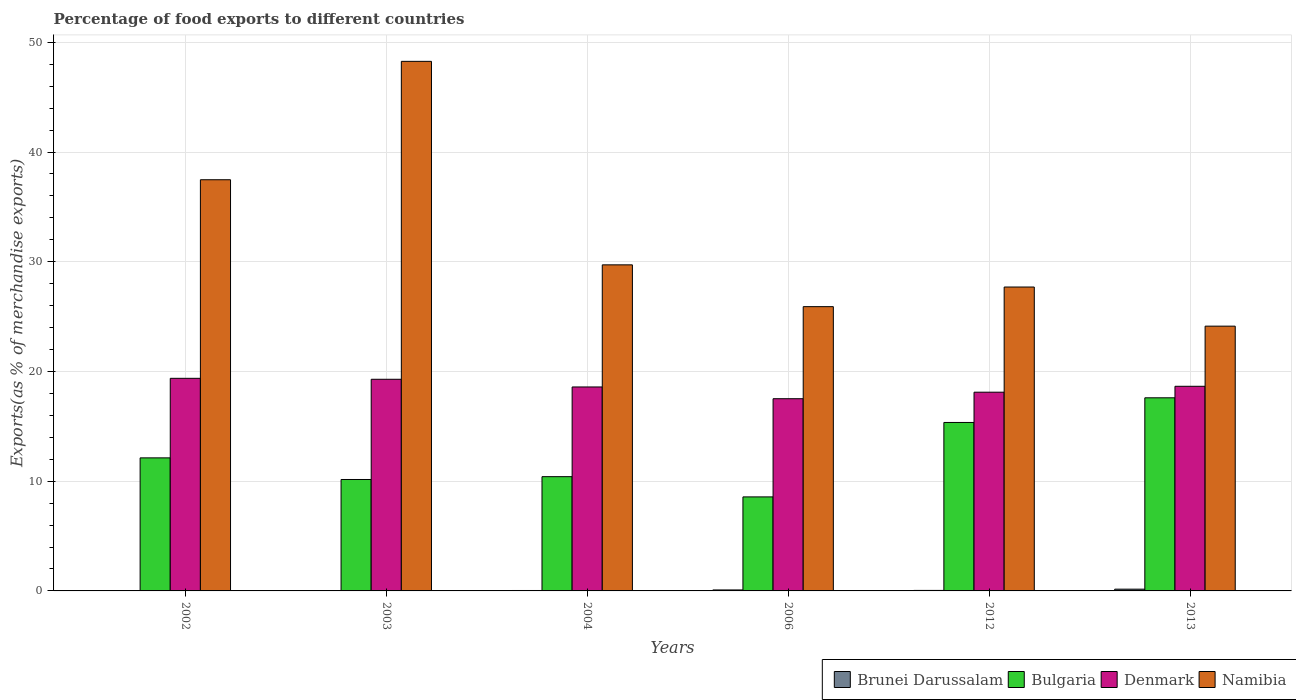How many different coloured bars are there?
Your answer should be compact. 4. Are the number of bars per tick equal to the number of legend labels?
Offer a very short reply. Yes. How many bars are there on the 6th tick from the left?
Ensure brevity in your answer.  4. What is the label of the 6th group of bars from the left?
Offer a very short reply. 2013. In how many cases, is the number of bars for a given year not equal to the number of legend labels?
Provide a succinct answer. 0. What is the percentage of exports to different countries in Denmark in 2002?
Your response must be concise. 19.38. Across all years, what is the maximum percentage of exports to different countries in Namibia?
Give a very brief answer. 48.27. Across all years, what is the minimum percentage of exports to different countries in Brunei Darussalam?
Offer a very short reply. 0.02. What is the total percentage of exports to different countries in Brunei Darussalam in the graph?
Offer a terse response. 0.37. What is the difference between the percentage of exports to different countries in Bulgaria in 2003 and that in 2006?
Provide a succinct answer. 1.59. What is the difference between the percentage of exports to different countries in Namibia in 2006 and the percentage of exports to different countries in Denmark in 2004?
Give a very brief answer. 7.32. What is the average percentage of exports to different countries in Brunei Darussalam per year?
Make the answer very short. 0.06. In the year 2006, what is the difference between the percentage of exports to different countries in Brunei Darussalam and percentage of exports to different countries in Bulgaria?
Provide a succinct answer. -8.48. What is the ratio of the percentage of exports to different countries in Denmark in 2002 to that in 2013?
Give a very brief answer. 1.04. Is the percentage of exports to different countries in Namibia in 2004 less than that in 2006?
Offer a very short reply. No. What is the difference between the highest and the second highest percentage of exports to different countries in Denmark?
Provide a short and direct response. 0.09. What is the difference between the highest and the lowest percentage of exports to different countries in Denmark?
Ensure brevity in your answer.  1.86. In how many years, is the percentage of exports to different countries in Bulgaria greater than the average percentage of exports to different countries in Bulgaria taken over all years?
Give a very brief answer. 2. Is the sum of the percentage of exports to different countries in Denmark in 2004 and 2013 greater than the maximum percentage of exports to different countries in Brunei Darussalam across all years?
Your answer should be compact. Yes. What does the 2nd bar from the left in 2006 represents?
Ensure brevity in your answer.  Bulgaria. What does the 3rd bar from the right in 2013 represents?
Keep it short and to the point. Bulgaria. How many years are there in the graph?
Provide a short and direct response. 6. What is the difference between two consecutive major ticks on the Y-axis?
Offer a terse response. 10. Does the graph contain grids?
Keep it short and to the point. Yes. How many legend labels are there?
Keep it short and to the point. 4. What is the title of the graph?
Offer a terse response. Percentage of food exports to different countries. Does "Uganda" appear as one of the legend labels in the graph?
Your answer should be very brief. No. What is the label or title of the Y-axis?
Your response must be concise. Exports(as % of merchandise exports). What is the Exports(as % of merchandise exports) of Brunei Darussalam in 2002?
Your answer should be compact. 0.02. What is the Exports(as % of merchandise exports) in Bulgaria in 2002?
Your answer should be very brief. 12.13. What is the Exports(as % of merchandise exports) of Denmark in 2002?
Provide a succinct answer. 19.38. What is the Exports(as % of merchandise exports) in Namibia in 2002?
Offer a very short reply. 37.48. What is the Exports(as % of merchandise exports) in Brunei Darussalam in 2003?
Offer a very short reply. 0.02. What is the Exports(as % of merchandise exports) in Bulgaria in 2003?
Offer a terse response. 10.16. What is the Exports(as % of merchandise exports) in Denmark in 2003?
Make the answer very short. 19.29. What is the Exports(as % of merchandise exports) of Namibia in 2003?
Your response must be concise. 48.27. What is the Exports(as % of merchandise exports) in Brunei Darussalam in 2004?
Your response must be concise. 0.04. What is the Exports(as % of merchandise exports) of Bulgaria in 2004?
Provide a succinct answer. 10.41. What is the Exports(as % of merchandise exports) in Denmark in 2004?
Provide a short and direct response. 18.59. What is the Exports(as % of merchandise exports) in Namibia in 2004?
Provide a succinct answer. 29.72. What is the Exports(as % of merchandise exports) in Brunei Darussalam in 2006?
Offer a terse response. 0.09. What is the Exports(as % of merchandise exports) in Bulgaria in 2006?
Offer a very short reply. 8.57. What is the Exports(as % of merchandise exports) of Denmark in 2006?
Your answer should be very brief. 17.52. What is the Exports(as % of merchandise exports) of Namibia in 2006?
Your answer should be very brief. 25.91. What is the Exports(as % of merchandise exports) of Brunei Darussalam in 2012?
Ensure brevity in your answer.  0.05. What is the Exports(as % of merchandise exports) in Bulgaria in 2012?
Ensure brevity in your answer.  15.35. What is the Exports(as % of merchandise exports) in Denmark in 2012?
Offer a terse response. 18.11. What is the Exports(as % of merchandise exports) of Namibia in 2012?
Keep it short and to the point. 27.7. What is the Exports(as % of merchandise exports) in Brunei Darussalam in 2013?
Your response must be concise. 0.16. What is the Exports(as % of merchandise exports) of Bulgaria in 2013?
Keep it short and to the point. 17.6. What is the Exports(as % of merchandise exports) in Denmark in 2013?
Make the answer very short. 18.65. What is the Exports(as % of merchandise exports) of Namibia in 2013?
Give a very brief answer. 24.13. Across all years, what is the maximum Exports(as % of merchandise exports) in Brunei Darussalam?
Offer a very short reply. 0.16. Across all years, what is the maximum Exports(as % of merchandise exports) of Bulgaria?
Ensure brevity in your answer.  17.6. Across all years, what is the maximum Exports(as % of merchandise exports) of Denmark?
Your response must be concise. 19.38. Across all years, what is the maximum Exports(as % of merchandise exports) of Namibia?
Make the answer very short. 48.27. Across all years, what is the minimum Exports(as % of merchandise exports) in Brunei Darussalam?
Provide a succinct answer. 0.02. Across all years, what is the minimum Exports(as % of merchandise exports) in Bulgaria?
Ensure brevity in your answer.  8.57. Across all years, what is the minimum Exports(as % of merchandise exports) in Denmark?
Give a very brief answer. 17.52. Across all years, what is the minimum Exports(as % of merchandise exports) in Namibia?
Offer a very short reply. 24.13. What is the total Exports(as % of merchandise exports) in Brunei Darussalam in the graph?
Keep it short and to the point. 0.37. What is the total Exports(as % of merchandise exports) in Bulgaria in the graph?
Give a very brief answer. 74.22. What is the total Exports(as % of merchandise exports) in Denmark in the graph?
Provide a succinct answer. 111.54. What is the total Exports(as % of merchandise exports) of Namibia in the graph?
Provide a short and direct response. 193.2. What is the difference between the Exports(as % of merchandise exports) of Bulgaria in 2002 and that in 2003?
Your answer should be compact. 1.97. What is the difference between the Exports(as % of merchandise exports) of Denmark in 2002 and that in 2003?
Your answer should be very brief. 0.09. What is the difference between the Exports(as % of merchandise exports) of Namibia in 2002 and that in 2003?
Your response must be concise. -10.79. What is the difference between the Exports(as % of merchandise exports) in Brunei Darussalam in 2002 and that in 2004?
Your answer should be very brief. -0.02. What is the difference between the Exports(as % of merchandise exports) of Bulgaria in 2002 and that in 2004?
Your answer should be very brief. 1.71. What is the difference between the Exports(as % of merchandise exports) in Denmark in 2002 and that in 2004?
Provide a succinct answer. 0.79. What is the difference between the Exports(as % of merchandise exports) in Namibia in 2002 and that in 2004?
Offer a terse response. 7.76. What is the difference between the Exports(as % of merchandise exports) of Brunei Darussalam in 2002 and that in 2006?
Provide a succinct answer. -0.07. What is the difference between the Exports(as % of merchandise exports) of Bulgaria in 2002 and that in 2006?
Offer a terse response. 3.56. What is the difference between the Exports(as % of merchandise exports) of Denmark in 2002 and that in 2006?
Ensure brevity in your answer.  1.86. What is the difference between the Exports(as % of merchandise exports) of Namibia in 2002 and that in 2006?
Ensure brevity in your answer.  11.57. What is the difference between the Exports(as % of merchandise exports) of Brunei Darussalam in 2002 and that in 2012?
Provide a succinct answer. -0.03. What is the difference between the Exports(as % of merchandise exports) of Bulgaria in 2002 and that in 2012?
Keep it short and to the point. -3.23. What is the difference between the Exports(as % of merchandise exports) in Denmark in 2002 and that in 2012?
Your response must be concise. 1.27. What is the difference between the Exports(as % of merchandise exports) in Namibia in 2002 and that in 2012?
Ensure brevity in your answer.  9.78. What is the difference between the Exports(as % of merchandise exports) of Brunei Darussalam in 2002 and that in 2013?
Offer a terse response. -0.14. What is the difference between the Exports(as % of merchandise exports) of Bulgaria in 2002 and that in 2013?
Offer a terse response. -5.47. What is the difference between the Exports(as % of merchandise exports) in Denmark in 2002 and that in 2013?
Your answer should be very brief. 0.73. What is the difference between the Exports(as % of merchandise exports) in Namibia in 2002 and that in 2013?
Your answer should be very brief. 13.35. What is the difference between the Exports(as % of merchandise exports) of Brunei Darussalam in 2003 and that in 2004?
Ensure brevity in your answer.  -0.02. What is the difference between the Exports(as % of merchandise exports) of Bulgaria in 2003 and that in 2004?
Provide a short and direct response. -0.26. What is the difference between the Exports(as % of merchandise exports) of Denmark in 2003 and that in 2004?
Give a very brief answer. 0.7. What is the difference between the Exports(as % of merchandise exports) in Namibia in 2003 and that in 2004?
Your answer should be compact. 18.55. What is the difference between the Exports(as % of merchandise exports) of Brunei Darussalam in 2003 and that in 2006?
Provide a succinct answer. -0.07. What is the difference between the Exports(as % of merchandise exports) in Bulgaria in 2003 and that in 2006?
Ensure brevity in your answer.  1.59. What is the difference between the Exports(as % of merchandise exports) in Denmark in 2003 and that in 2006?
Ensure brevity in your answer.  1.77. What is the difference between the Exports(as % of merchandise exports) in Namibia in 2003 and that in 2006?
Keep it short and to the point. 22.36. What is the difference between the Exports(as % of merchandise exports) of Brunei Darussalam in 2003 and that in 2012?
Provide a short and direct response. -0.03. What is the difference between the Exports(as % of merchandise exports) in Bulgaria in 2003 and that in 2012?
Your response must be concise. -5.2. What is the difference between the Exports(as % of merchandise exports) of Denmark in 2003 and that in 2012?
Your response must be concise. 1.18. What is the difference between the Exports(as % of merchandise exports) of Namibia in 2003 and that in 2012?
Your response must be concise. 20.57. What is the difference between the Exports(as % of merchandise exports) of Brunei Darussalam in 2003 and that in 2013?
Provide a succinct answer. -0.14. What is the difference between the Exports(as % of merchandise exports) in Bulgaria in 2003 and that in 2013?
Ensure brevity in your answer.  -7.44. What is the difference between the Exports(as % of merchandise exports) of Denmark in 2003 and that in 2013?
Give a very brief answer. 0.64. What is the difference between the Exports(as % of merchandise exports) in Namibia in 2003 and that in 2013?
Give a very brief answer. 24.14. What is the difference between the Exports(as % of merchandise exports) in Brunei Darussalam in 2004 and that in 2006?
Ensure brevity in your answer.  -0.05. What is the difference between the Exports(as % of merchandise exports) of Bulgaria in 2004 and that in 2006?
Make the answer very short. 1.84. What is the difference between the Exports(as % of merchandise exports) in Denmark in 2004 and that in 2006?
Your answer should be compact. 1.07. What is the difference between the Exports(as % of merchandise exports) in Namibia in 2004 and that in 2006?
Give a very brief answer. 3.81. What is the difference between the Exports(as % of merchandise exports) in Brunei Darussalam in 2004 and that in 2012?
Ensure brevity in your answer.  -0.01. What is the difference between the Exports(as % of merchandise exports) in Bulgaria in 2004 and that in 2012?
Give a very brief answer. -4.94. What is the difference between the Exports(as % of merchandise exports) of Denmark in 2004 and that in 2012?
Your answer should be very brief. 0.48. What is the difference between the Exports(as % of merchandise exports) of Namibia in 2004 and that in 2012?
Your answer should be compact. 2.02. What is the difference between the Exports(as % of merchandise exports) of Brunei Darussalam in 2004 and that in 2013?
Your answer should be very brief. -0.12. What is the difference between the Exports(as % of merchandise exports) of Bulgaria in 2004 and that in 2013?
Make the answer very short. -7.19. What is the difference between the Exports(as % of merchandise exports) of Denmark in 2004 and that in 2013?
Provide a short and direct response. -0.06. What is the difference between the Exports(as % of merchandise exports) in Namibia in 2004 and that in 2013?
Offer a terse response. 5.59. What is the difference between the Exports(as % of merchandise exports) in Brunei Darussalam in 2006 and that in 2012?
Offer a very short reply. 0.04. What is the difference between the Exports(as % of merchandise exports) in Bulgaria in 2006 and that in 2012?
Provide a short and direct response. -6.79. What is the difference between the Exports(as % of merchandise exports) in Denmark in 2006 and that in 2012?
Your answer should be very brief. -0.59. What is the difference between the Exports(as % of merchandise exports) of Namibia in 2006 and that in 2012?
Ensure brevity in your answer.  -1.79. What is the difference between the Exports(as % of merchandise exports) of Brunei Darussalam in 2006 and that in 2013?
Keep it short and to the point. -0.07. What is the difference between the Exports(as % of merchandise exports) of Bulgaria in 2006 and that in 2013?
Offer a terse response. -9.03. What is the difference between the Exports(as % of merchandise exports) of Denmark in 2006 and that in 2013?
Your response must be concise. -1.13. What is the difference between the Exports(as % of merchandise exports) of Namibia in 2006 and that in 2013?
Provide a succinct answer. 1.78. What is the difference between the Exports(as % of merchandise exports) in Brunei Darussalam in 2012 and that in 2013?
Provide a succinct answer. -0.11. What is the difference between the Exports(as % of merchandise exports) of Bulgaria in 2012 and that in 2013?
Provide a short and direct response. -2.25. What is the difference between the Exports(as % of merchandise exports) of Denmark in 2012 and that in 2013?
Your answer should be very brief. -0.54. What is the difference between the Exports(as % of merchandise exports) of Namibia in 2012 and that in 2013?
Make the answer very short. 3.57. What is the difference between the Exports(as % of merchandise exports) in Brunei Darussalam in 2002 and the Exports(as % of merchandise exports) in Bulgaria in 2003?
Your answer should be very brief. -10.14. What is the difference between the Exports(as % of merchandise exports) in Brunei Darussalam in 2002 and the Exports(as % of merchandise exports) in Denmark in 2003?
Give a very brief answer. -19.27. What is the difference between the Exports(as % of merchandise exports) of Brunei Darussalam in 2002 and the Exports(as % of merchandise exports) of Namibia in 2003?
Offer a very short reply. -48.25. What is the difference between the Exports(as % of merchandise exports) of Bulgaria in 2002 and the Exports(as % of merchandise exports) of Denmark in 2003?
Your response must be concise. -7.16. What is the difference between the Exports(as % of merchandise exports) of Bulgaria in 2002 and the Exports(as % of merchandise exports) of Namibia in 2003?
Your answer should be very brief. -36.14. What is the difference between the Exports(as % of merchandise exports) of Denmark in 2002 and the Exports(as % of merchandise exports) of Namibia in 2003?
Your answer should be very brief. -28.89. What is the difference between the Exports(as % of merchandise exports) in Brunei Darussalam in 2002 and the Exports(as % of merchandise exports) in Bulgaria in 2004?
Offer a very short reply. -10.39. What is the difference between the Exports(as % of merchandise exports) of Brunei Darussalam in 2002 and the Exports(as % of merchandise exports) of Denmark in 2004?
Provide a succinct answer. -18.57. What is the difference between the Exports(as % of merchandise exports) of Brunei Darussalam in 2002 and the Exports(as % of merchandise exports) of Namibia in 2004?
Your answer should be very brief. -29.7. What is the difference between the Exports(as % of merchandise exports) of Bulgaria in 2002 and the Exports(as % of merchandise exports) of Denmark in 2004?
Your answer should be very brief. -6.46. What is the difference between the Exports(as % of merchandise exports) in Bulgaria in 2002 and the Exports(as % of merchandise exports) in Namibia in 2004?
Keep it short and to the point. -17.59. What is the difference between the Exports(as % of merchandise exports) in Denmark in 2002 and the Exports(as % of merchandise exports) in Namibia in 2004?
Your response must be concise. -10.34. What is the difference between the Exports(as % of merchandise exports) of Brunei Darussalam in 2002 and the Exports(as % of merchandise exports) of Bulgaria in 2006?
Offer a very short reply. -8.55. What is the difference between the Exports(as % of merchandise exports) of Brunei Darussalam in 2002 and the Exports(as % of merchandise exports) of Denmark in 2006?
Your answer should be very brief. -17.5. What is the difference between the Exports(as % of merchandise exports) of Brunei Darussalam in 2002 and the Exports(as % of merchandise exports) of Namibia in 2006?
Make the answer very short. -25.89. What is the difference between the Exports(as % of merchandise exports) in Bulgaria in 2002 and the Exports(as % of merchandise exports) in Denmark in 2006?
Your response must be concise. -5.39. What is the difference between the Exports(as % of merchandise exports) of Bulgaria in 2002 and the Exports(as % of merchandise exports) of Namibia in 2006?
Provide a succinct answer. -13.78. What is the difference between the Exports(as % of merchandise exports) in Denmark in 2002 and the Exports(as % of merchandise exports) in Namibia in 2006?
Your answer should be compact. -6.53. What is the difference between the Exports(as % of merchandise exports) of Brunei Darussalam in 2002 and the Exports(as % of merchandise exports) of Bulgaria in 2012?
Offer a very short reply. -15.33. What is the difference between the Exports(as % of merchandise exports) of Brunei Darussalam in 2002 and the Exports(as % of merchandise exports) of Denmark in 2012?
Your answer should be very brief. -18.09. What is the difference between the Exports(as % of merchandise exports) of Brunei Darussalam in 2002 and the Exports(as % of merchandise exports) of Namibia in 2012?
Provide a succinct answer. -27.68. What is the difference between the Exports(as % of merchandise exports) of Bulgaria in 2002 and the Exports(as % of merchandise exports) of Denmark in 2012?
Keep it short and to the point. -5.99. What is the difference between the Exports(as % of merchandise exports) in Bulgaria in 2002 and the Exports(as % of merchandise exports) in Namibia in 2012?
Make the answer very short. -15.57. What is the difference between the Exports(as % of merchandise exports) in Denmark in 2002 and the Exports(as % of merchandise exports) in Namibia in 2012?
Ensure brevity in your answer.  -8.32. What is the difference between the Exports(as % of merchandise exports) in Brunei Darussalam in 2002 and the Exports(as % of merchandise exports) in Bulgaria in 2013?
Your answer should be very brief. -17.58. What is the difference between the Exports(as % of merchandise exports) of Brunei Darussalam in 2002 and the Exports(as % of merchandise exports) of Denmark in 2013?
Offer a very short reply. -18.63. What is the difference between the Exports(as % of merchandise exports) of Brunei Darussalam in 2002 and the Exports(as % of merchandise exports) of Namibia in 2013?
Provide a short and direct response. -24.11. What is the difference between the Exports(as % of merchandise exports) in Bulgaria in 2002 and the Exports(as % of merchandise exports) in Denmark in 2013?
Keep it short and to the point. -6.52. What is the difference between the Exports(as % of merchandise exports) of Bulgaria in 2002 and the Exports(as % of merchandise exports) of Namibia in 2013?
Offer a very short reply. -12.01. What is the difference between the Exports(as % of merchandise exports) in Denmark in 2002 and the Exports(as % of merchandise exports) in Namibia in 2013?
Your answer should be very brief. -4.75. What is the difference between the Exports(as % of merchandise exports) of Brunei Darussalam in 2003 and the Exports(as % of merchandise exports) of Bulgaria in 2004?
Ensure brevity in your answer.  -10.39. What is the difference between the Exports(as % of merchandise exports) in Brunei Darussalam in 2003 and the Exports(as % of merchandise exports) in Denmark in 2004?
Your answer should be very brief. -18.57. What is the difference between the Exports(as % of merchandise exports) of Brunei Darussalam in 2003 and the Exports(as % of merchandise exports) of Namibia in 2004?
Offer a very short reply. -29.7. What is the difference between the Exports(as % of merchandise exports) of Bulgaria in 2003 and the Exports(as % of merchandise exports) of Denmark in 2004?
Make the answer very short. -8.43. What is the difference between the Exports(as % of merchandise exports) in Bulgaria in 2003 and the Exports(as % of merchandise exports) in Namibia in 2004?
Offer a very short reply. -19.56. What is the difference between the Exports(as % of merchandise exports) in Denmark in 2003 and the Exports(as % of merchandise exports) in Namibia in 2004?
Your response must be concise. -10.43. What is the difference between the Exports(as % of merchandise exports) in Brunei Darussalam in 2003 and the Exports(as % of merchandise exports) in Bulgaria in 2006?
Your response must be concise. -8.55. What is the difference between the Exports(as % of merchandise exports) of Brunei Darussalam in 2003 and the Exports(as % of merchandise exports) of Denmark in 2006?
Your answer should be compact. -17.5. What is the difference between the Exports(as % of merchandise exports) of Brunei Darussalam in 2003 and the Exports(as % of merchandise exports) of Namibia in 2006?
Your response must be concise. -25.89. What is the difference between the Exports(as % of merchandise exports) in Bulgaria in 2003 and the Exports(as % of merchandise exports) in Denmark in 2006?
Provide a succinct answer. -7.36. What is the difference between the Exports(as % of merchandise exports) in Bulgaria in 2003 and the Exports(as % of merchandise exports) in Namibia in 2006?
Your response must be concise. -15.75. What is the difference between the Exports(as % of merchandise exports) of Denmark in 2003 and the Exports(as % of merchandise exports) of Namibia in 2006?
Your answer should be very brief. -6.62. What is the difference between the Exports(as % of merchandise exports) in Brunei Darussalam in 2003 and the Exports(as % of merchandise exports) in Bulgaria in 2012?
Make the answer very short. -15.33. What is the difference between the Exports(as % of merchandise exports) in Brunei Darussalam in 2003 and the Exports(as % of merchandise exports) in Denmark in 2012?
Make the answer very short. -18.09. What is the difference between the Exports(as % of merchandise exports) of Brunei Darussalam in 2003 and the Exports(as % of merchandise exports) of Namibia in 2012?
Give a very brief answer. -27.68. What is the difference between the Exports(as % of merchandise exports) in Bulgaria in 2003 and the Exports(as % of merchandise exports) in Denmark in 2012?
Provide a succinct answer. -7.96. What is the difference between the Exports(as % of merchandise exports) of Bulgaria in 2003 and the Exports(as % of merchandise exports) of Namibia in 2012?
Your response must be concise. -17.54. What is the difference between the Exports(as % of merchandise exports) of Denmark in 2003 and the Exports(as % of merchandise exports) of Namibia in 2012?
Give a very brief answer. -8.41. What is the difference between the Exports(as % of merchandise exports) of Brunei Darussalam in 2003 and the Exports(as % of merchandise exports) of Bulgaria in 2013?
Offer a very short reply. -17.58. What is the difference between the Exports(as % of merchandise exports) in Brunei Darussalam in 2003 and the Exports(as % of merchandise exports) in Denmark in 2013?
Offer a terse response. -18.63. What is the difference between the Exports(as % of merchandise exports) in Brunei Darussalam in 2003 and the Exports(as % of merchandise exports) in Namibia in 2013?
Provide a short and direct response. -24.11. What is the difference between the Exports(as % of merchandise exports) of Bulgaria in 2003 and the Exports(as % of merchandise exports) of Denmark in 2013?
Offer a terse response. -8.5. What is the difference between the Exports(as % of merchandise exports) of Bulgaria in 2003 and the Exports(as % of merchandise exports) of Namibia in 2013?
Your answer should be very brief. -13.98. What is the difference between the Exports(as % of merchandise exports) of Denmark in 2003 and the Exports(as % of merchandise exports) of Namibia in 2013?
Provide a short and direct response. -4.84. What is the difference between the Exports(as % of merchandise exports) in Brunei Darussalam in 2004 and the Exports(as % of merchandise exports) in Bulgaria in 2006?
Your answer should be compact. -8.53. What is the difference between the Exports(as % of merchandise exports) of Brunei Darussalam in 2004 and the Exports(as % of merchandise exports) of Denmark in 2006?
Ensure brevity in your answer.  -17.48. What is the difference between the Exports(as % of merchandise exports) in Brunei Darussalam in 2004 and the Exports(as % of merchandise exports) in Namibia in 2006?
Your answer should be very brief. -25.87. What is the difference between the Exports(as % of merchandise exports) of Bulgaria in 2004 and the Exports(as % of merchandise exports) of Denmark in 2006?
Offer a terse response. -7.11. What is the difference between the Exports(as % of merchandise exports) of Bulgaria in 2004 and the Exports(as % of merchandise exports) of Namibia in 2006?
Keep it short and to the point. -15.5. What is the difference between the Exports(as % of merchandise exports) in Denmark in 2004 and the Exports(as % of merchandise exports) in Namibia in 2006?
Ensure brevity in your answer.  -7.32. What is the difference between the Exports(as % of merchandise exports) of Brunei Darussalam in 2004 and the Exports(as % of merchandise exports) of Bulgaria in 2012?
Give a very brief answer. -15.32. What is the difference between the Exports(as % of merchandise exports) of Brunei Darussalam in 2004 and the Exports(as % of merchandise exports) of Denmark in 2012?
Offer a very short reply. -18.07. What is the difference between the Exports(as % of merchandise exports) of Brunei Darussalam in 2004 and the Exports(as % of merchandise exports) of Namibia in 2012?
Your response must be concise. -27.66. What is the difference between the Exports(as % of merchandise exports) in Bulgaria in 2004 and the Exports(as % of merchandise exports) in Denmark in 2012?
Make the answer very short. -7.7. What is the difference between the Exports(as % of merchandise exports) in Bulgaria in 2004 and the Exports(as % of merchandise exports) in Namibia in 2012?
Provide a succinct answer. -17.29. What is the difference between the Exports(as % of merchandise exports) in Denmark in 2004 and the Exports(as % of merchandise exports) in Namibia in 2012?
Your answer should be very brief. -9.11. What is the difference between the Exports(as % of merchandise exports) of Brunei Darussalam in 2004 and the Exports(as % of merchandise exports) of Bulgaria in 2013?
Your answer should be compact. -17.56. What is the difference between the Exports(as % of merchandise exports) of Brunei Darussalam in 2004 and the Exports(as % of merchandise exports) of Denmark in 2013?
Your response must be concise. -18.61. What is the difference between the Exports(as % of merchandise exports) in Brunei Darussalam in 2004 and the Exports(as % of merchandise exports) in Namibia in 2013?
Give a very brief answer. -24.09. What is the difference between the Exports(as % of merchandise exports) of Bulgaria in 2004 and the Exports(as % of merchandise exports) of Denmark in 2013?
Give a very brief answer. -8.24. What is the difference between the Exports(as % of merchandise exports) of Bulgaria in 2004 and the Exports(as % of merchandise exports) of Namibia in 2013?
Give a very brief answer. -13.72. What is the difference between the Exports(as % of merchandise exports) of Denmark in 2004 and the Exports(as % of merchandise exports) of Namibia in 2013?
Provide a short and direct response. -5.54. What is the difference between the Exports(as % of merchandise exports) in Brunei Darussalam in 2006 and the Exports(as % of merchandise exports) in Bulgaria in 2012?
Your response must be concise. -15.27. What is the difference between the Exports(as % of merchandise exports) in Brunei Darussalam in 2006 and the Exports(as % of merchandise exports) in Denmark in 2012?
Ensure brevity in your answer.  -18.02. What is the difference between the Exports(as % of merchandise exports) in Brunei Darussalam in 2006 and the Exports(as % of merchandise exports) in Namibia in 2012?
Provide a succinct answer. -27.61. What is the difference between the Exports(as % of merchandise exports) in Bulgaria in 2006 and the Exports(as % of merchandise exports) in Denmark in 2012?
Make the answer very short. -9.54. What is the difference between the Exports(as % of merchandise exports) of Bulgaria in 2006 and the Exports(as % of merchandise exports) of Namibia in 2012?
Offer a terse response. -19.13. What is the difference between the Exports(as % of merchandise exports) of Denmark in 2006 and the Exports(as % of merchandise exports) of Namibia in 2012?
Make the answer very short. -10.18. What is the difference between the Exports(as % of merchandise exports) of Brunei Darussalam in 2006 and the Exports(as % of merchandise exports) of Bulgaria in 2013?
Give a very brief answer. -17.51. What is the difference between the Exports(as % of merchandise exports) of Brunei Darussalam in 2006 and the Exports(as % of merchandise exports) of Denmark in 2013?
Offer a very short reply. -18.56. What is the difference between the Exports(as % of merchandise exports) of Brunei Darussalam in 2006 and the Exports(as % of merchandise exports) of Namibia in 2013?
Ensure brevity in your answer.  -24.04. What is the difference between the Exports(as % of merchandise exports) of Bulgaria in 2006 and the Exports(as % of merchandise exports) of Denmark in 2013?
Provide a short and direct response. -10.08. What is the difference between the Exports(as % of merchandise exports) in Bulgaria in 2006 and the Exports(as % of merchandise exports) in Namibia in 2013?
Offer a terse response. -15.56. What is the difference between the Exports(as % of merchandise exports) in Denmark in 2006 and the Exports(as % of merchandise exports) in Namibia in 2013?
Offer a very short reply. -6.61. What is the difference between the Exports(as % of merchandise exports) in Brunei Darussalam in 2012 and the Exports(as % of merchandise exports) in Bulgaria in 2013?
Provide a short and direct response. -17.55. What is the difference between the Exports(as % of merchandise exports) in Brunei Darussalam in 2012 and the Exports(as % of merchandise exports) in Denmark in 2013?
Provide a succinct answer. -18.61. What is the difference between the Exports(as % of merchandise exports) in Brunei Darussalam in 2012 and the Exports(as % of merchandise exports) in Namibia in 2013?
Give a very brief answer. -24.09. What is the difference between the Exports(as % of merchandise exports) of Bulgaria in 2012 and the Exports(as % of merchandise exports) of Denmark in 2013?
Make the answer very short. -3.3. What is the difference between the Exports(as % of merchandise exports) of Bulgaria in 2012 and the Exports(as % of merchandise exports) of Namibia in 2013?
Offer a terse response. -8.78. What is the difference between the Exports(as % of merchandise exports) of Denmark in 2012 and the Exports(as % of merchandise exports) of Namibia in 2013?
Offer a terse response. -6.02. What is the average Exports(as % of merchandise exports) of Brunei Darussalam per year?
Offer a terse response. 0.06. What is the average Exports(as % of merchandise exports) in Bulgaria per year?
Give a very brief answer. 12.37. What is the average Exports(as % of merchandise exports) in Denmark per year?
Your answer should be compact. 18.59. What is the average Exports(as % of merchandise exports) in Namibia per year?
Your response must be concise. 32.2. In the year 2002, what is the difference between the Exports(as % of merchandise exports) in Brunei Darussalam and Exports(as % of merchandise exports) in Bulgaria?
Ensure brevity in your answer.  -12.11. In the year 2002, what is the difference between the Exports(as % of merchandise exports) of Brunei Darussalam and Exports(as % of merchandise exports) of Denmark?
Offer a terse response. -19.36. In the year 2002, what is the difference between the Exports(as % of merchandise exports) of Brunei Darussalam and Exports(as % of merchandise exports) of Namibia?
Offer a terse response. -37.46. In the year 2002, what is the difference between the Exports(as % of merchandise exports) in Bulgaria and Exports(as % of merchandise exports) in Denmark?
Give a very brief answer. -7.25. In the year 2002, what is the difference between the Exports(as % of merchandise exports) in Bulgaria and Exports(as % of merchandise exports) in Namibia?
Provide a succinct answer. -25.35. In the year 2002, what is the difference between the Exports(as % of merchandise exports) in Denmark and Exports(as % of merchandise exports) in Namibia?
Provide a short and direct response. -18.1. In the year 2003, what is the difference between the Exports(as % of merchandise exports) of Brunei Darussalam and Exports(as % of merchandise exports) of Bulgaria?
Offer a very short reply. -10.14. In the year 2003, what is the difference between the Exports(as % of merchandise exports) in Brunei Darussalam and Exports(as % of merchandise exports) in Denmark?
Provide a short and direct response. -19.27. In the year 2003, what is the difference between the Exports(as % of merchandise exports) in Brunei Darussalam and Exports(as % of merchandise exports) in Namibia?
Provide a succinct answer. -48.25. In the year 2003, what is the difference between the Exports(as % of merchandise exports) in Bulgaria and Exports(as % of merchandise exports) in Denmark?
Offer a very short reply. -9.13. In the year 2003, what is the difference between the Exports(as % of merchandise exports) in Bulgaria and Exports(as % of merchandise exports) in Namibia?
Your answer should be compact. -38.11. In the year 2003, what is the difference between the Exports(as % of merchandise exports) of Denmark and Exports(as % of merchandise exports) of Namibia?
Your answer should be very brief. -28.98. In the year 2004, what is the difference between the Exports(as % of merchandise exports) in Brunei Darussalam and Exports(as % of merchandise exports) in Bulgaria?
Offer a terse response. -10.37. In the year 2004, what is the difference between the Exports(as % of merchandise exports) of Brunei Darussalam and Exports(as % of merchandise exports) of Denmark?
Provide a succinct answer. -18.55. In the year 2004, what is the difference between the Exports(as % of merchandise exports) in Brunei Darussalam and Exports(as % of merchandise exports) in Namibia?
Your answer should be very brief. -29.68. In the year 2004, what is the difference between the Exports(as % of merchandise exports) in Bulgaria and Exports(as % of merchandise exports) in Denmark?
Your answer should be very brief. -8.18. In the year 2004, what is the difference between the Exports(as % of merchandise exports) in Bulgaria and Exports(as % of merchandise exports) in Namibia?
Your response must be concise. -19.31. In the year 2004, what is the difference between the Exports(as % of merchandise exports) in Denmark and Exports(as % of merchandise exports) in Namibia?
Make the answer very short. -11.13. In the year 2006, what is the difference between the Exports(as % of merchandise exports) of Brunei Darussalam and Exports(as % of merchandise exports) of Bulgaria?
Provide a short and direct response. -8.48. In the year 2006, what is the difference between the Exports(as % of merchandise exports) of Brunei Darussalam and Exports(as % of merchandise exports) of Denmark?
Give a very brief answer. -17.43. In the year 2006, what is the difference between the Exports(as % of merchandise exports) of Brunei Darussalam and Exports(as % of merchandise exports) of Namibia?
Your answer should be very brief. -25.82. In the year 2006, what is the difference between the Exports(as % of merchandise exports) of Bulgaria and Exports(as % of merchandise exports) of Denmark?
Offer a terse response. -8.95. In the year 2006, what is the difference between the Exports(as % of merchandise exports) in Bulgaria and Exports(as % of merchandise exports) in Namibia?
Your answer should be compact. -17.34. In the year 2006, what is the difference between the Exports(as % of merchandise exports) of Denmark and Exports(as % of merchandise exports) of Namibia?
Offer a terse response. -8.39. In the year 2012, what is the difference between the Exports(as % of merchandise exports) in Brunei Darussalam and Exports(as % of merchandise exports) in Bulgaria?
Ensure brevity in your answer.  -15.31. In the year 2012, what is the difference between the Exports(as % of merchandise exports) of Brunei Darussalam and Exports(as % of merchandise exports) of Denmark?
Provide a short and direct response. -18.07. In the year 2012, what is the difference between the Exports(as % of merchandise exports) in Brunei Darussalam and Exports(as % of merchandise exports) in Namibia?
Your answer should be very brief. -27.65. In the year 2012, what is the difference between the Exports(as % of merchandise exports) of Bulgaria and Exports(as % of merchandise exports) of Denmark?
Keep it short and to the point. -2.76. In the year 2012, what is the difference between the Exports(as % of merchandise exports) in Bulgaria and Exports(as % of merchandise exports) in Namibia?
Offer a terse response. -12.34. In the year 2012, what is the difference between the Exports(as % of merchandise exports) of Denmark and Exports(as % of merchandise exports) of Namibia?
Your answer should be very brief. -9.59. In the year 2013, what is the difference between the Exports(as % of merchandise exports) in Brunei Darussalam and Exports(as % of merchandise exports) in Bulgaria?
Give a very brief answer. -17.44. In the year 2013, what is the difference between the Exports(as % of merchandise exports) of Brunei Darussalam and Exports(as % of merchandise exports) of Denmark?
Your response must be concise. -18.49. In the year 2013, what is the difference between the Exports(as % of merchandise exports) of Brunei Darussalam and Exports(as % of merchandise exports) of Namibia?
Offer a terse response. -23.97. In the year 2013, what is the difference between the Exports(as % of merchandise exports) of Bulgaria and Exports(as % of merchandise exports) of Denmark?
Your answer should be compact. -1.05. In the year 2013, what is the difference between the Exports(as % of merchandise exports) of Bulgaria and Exports(as % of merchandise exports) of Namibia?
Your answer should be very brief. -6.53. In the year 2013, what is the difference between the Exports(as % of merchandise exports) in Denmark and Exports(as % of merchandise exports) in Namibia?
Keep it short and to the point. -5.48. What is the ratio of the Exports(as % of merchandise exports) in Brunei Darussalam in 2002 to that in 2003?
Offer a very short reply. 1.01. What is the ratio of the Exports(as % of merchandise exports) of Bulgaria in 2002 to that in 2003?
Ensure brevity in your answer.  1.19. What is the ratio of the Exports(as % of merchandise exports) in Denmark in 2002 to that in 2003?
Your response must be concise. 1. What is the ratio of the Exports(as % of merchandise exports) in Namibia in 2002 to that in 2003?
Provide a succinct answer. 0.78. What is the ratio of the Exports(as % of merchandise exports) of Brunei Darussalam in 2002 to that in 2004?
Offer a very short reply. 0.52. What is the ratio of the Exports(as % of merchandise exports) in Bulgaria in 2002 to that in 2004?
Offer a very short reply. 1.16. What is the ratio of the Exports(as % of merchandise exports) of Denmark in 2002 to that in 2004?
Ensure brevity in your answer.  1.04. What is the ratio of the Exports(as % of merchandise exports) in Namibia in 2002 to that in 2004?
Give a very brief answer. 1.26. What is the ratio of the Exports(as % of merchandise exports) in Brunei Darussalam in 2002 to that in 2006?
Give a very brief answer. 0.23. What is the ratio of the Exports(as % of merchandise exports) of Bulgaria in 2002 to that in 2006?
Provide a succinct answer. 1.42. What is the ratio of the Exports(as % of merchandise exports) in Denmark in 2002 to that in 2006?
Provide a succinct answer. 1.11. What is the ratio of the Exports(as % of merchandise exports) in Namibia in 2002 to that in 2006?
Keep it short and to the point. 1.45. What is the ratio of the Exports(as % of merchandise exports) of Brunei Darussalam in 2002 to that in 2012?
Your answer should be very brief. 0.44. What is the ratio of the Exports(as % of merchandise exports) of Bulgaria in 2002 to that in 2012?
Ensure brevity in your answer.  0.79. What is the ratio of the Exports(as % of merchandise exports) of Denmark in 2002 to that in 2012?
Give a very brief answer. 1.07. What is the ratio of the Exports(as % of merchandise exports) in Namibia in 2002 to that in 2012?
Your response must be concise. 1.35. What is the ratio of the Exports(as % of merchandise exports) in Brunei Darussalam in 2002 to that in 2013?
Your answer should be very brief. 0.13. What is the ratio of the Exports(as % of merchandise exports) of Bulgaria in 2002 to that in 2013?
Provide a short and direct response. 0.69. What is the ratio of the Exports(as % of merchandise exports) of Denmark in 2002 to that in 2013?
Your answer should be very brief. 1.04. What is the ratio of the Exports(as % of merchandise exports) in Namibia in 2002 to that in 2013?
Make the answer very short. 1.55. What is the ratio of the Exports(as % of merchandise exports) of Brunei Darussalam in 2003 to that in 2004?
Your answer should be compact. 0.51. What is the ratio of the Exports(as % of merchandise exports) in Bulgaria in 2003 to that in 2004?
Keep it short and to the point. 0.98. What is the ratio of the Exports(as % of merchandise exports) of Denmark in 2003 to that in 2004?
Your response must be concise. 1.04. What is the ratio of the Exports(as % of merchandise exports) in Namibia in 2003 to that in 2004?
Offer a very short reply. 1.62. What is the ratio of the Exports(as % of merchandise exports) of Brunei Darussalam in 2003 to that in 2006?
Keep it short and to the point. 0.23. What is the ratio of the Exports(as % of merchandise exports) of Bulgaria in 2003 to that in 2006?
Keep it short and to the point. 1.19. What is the ratio of the Exports(as % of merchandise exports) in Denmark in 2003 to that in 2006?
Keep it short and to the point. 1.1. What is the ratio of the Exports(as % of merchandise exports) of Namibia in 2003 to that in 2006?
Give a very brief answer. 1.86. What is the ratio of the Exports(as % of merchandise exports) in Brunei Darussalam in 2003 to that in 2012?
Offer a terse response. 0.44. What is the ratio of the Exports(as % of merchandise exports) of Bulgaria in 2003 to that in 2012?
Keep it short and to the point. 0.66. What is the ratio of the Exports(as % of merchandise exports) in Denmark in 2003 to that in 2012?
Your answer should be compact. 1.06. What is the ratio of the Exports(as % of merchandise exports) of Namibia in 2003 to that in 2012?
Make the answer very short. 1.74. What is the ratio of the Exports(as % of merchandise exports) in Brunei Darussalam in 2003 to that in 2013?
Provide a succinct answer. 0.13. What is the ratio of the Exports(as % of merchandise exports) in Bulgaria in 2003 to that in 2013?
Make the answer very short. 0.58. What is the ratio of the Exports(as % of merchandise exports) of Denmark in 2003 to that in 2013?
Offer a very short reply. 1.03. What is the ratio of the Exports(as % of merchandise exports) of Namibia in 2003 to that in 2013?
Make the answer very short. 2. What is the ratio of the Exports(as % of merchandise exports) of Brunei Darussalam in 2004 to that in 2006?
Make the answer very short. 0.44. What is the ratio of the Exports(as % of merchandise exports) in Bulgaria in 2004 to that in 2006?
Your answer should be very brief. 1.22. What is the ratio of the Exports(as % of merchandise exports) in Denmark in 2004 to that in 2006?
Your answer should be compact. 1.06. What is the ratio of the Exports(as % of merchandise exports) in Namibia in 2004 to that in 2006?
Your answer should be very brief. 1.15. What is the ratio of the Exports(as % of merchandise exports) of Brunei Darussalam in 2004 to that in 2012?
Offer a very short reply. 0.85. What is the ratio of the Exports(as % of merchandise exports) in Bulgaria in 2004 to that in 2012?
Keep it short and to the point. 0.68. What is the ratio of the Exports(as % of merchandise exports) of Denmark in 2004 to that in 2012?
Provide a short and direct response. 1.03. What is the ratio of the Exports(as % of merchandise exports) of Namibia in 2004 to that in 2012?
Offer a terse response. 1.07. What is the ratio of the Exports(as % of merchandise exports) in Brunei Darussalam in 2004 to that in 2013?
Ensure brevity in your answer.  0.24. What is the ratio of the Exports(as % of merchandise exports) in Bulgaria in 2004 to that in 2013?
Keep it short and to the point. 0.59. What is the ratio of the Exports(as % of merchandise exports) of Denmark in 2004 to that in 2013?
Offer a terse response. 1. What is the ratio of the Exports(as % of merchandise exports) of Namibia in 2004 to that in 2013?
Your response must be concise. 1.23. What is the ratio of the Exports(as % of merchandise exports) of Brunei Darussalam in 2006 to that in 2012?
Keep it short and to the point. 1.93. What is the ratio of the Exports(as % of merchandise exports) of Bulgaria in 2006 to that in 2012?
Offer a terse response. 0.56. What is the ratio of the Exports(as % of merchandise exports) in Denmark in 2006 to that in 2012?
Offer a terse response. 0.97. What is the ratio of the Exports(as % of merchandise exports) in Namibia in 2006 to that in 2012?
Your answer should be very brief. 0.94. What is the ratio of the Exports(as % of merchandise exports) of Brunei Darussalam in 2006 to that in 2013?
Offer a very short reply. 0.55. What is the ratio of the Exports(as % of merchandise exports) of Bulgaria in 2006 to that in 2013?
Your answer should be compact. 0.49. What is the ratio of the Exports(as % of merchandise exports) in Denmark in 2006 to that in 2013?
Ensure brevity in your answer.  0.94. What is the ratio of the Exports(as % of merchandise exports) of Namibia in 2006 to that in 2013?
Your answer should be compact. 1.07. What is the ratio of the Exports(as % of merchandise exports) in Brunei Darussalam in 2012 to that in 2013?
Keep it short and to the point. 0.29. What is the ratio of the Exports(as % of merchandise exports) of Bulgaria in 2012 to that in 2013?
Provide a succinct answer. 0.87. What is the ratio of the Exports(as % of merchandise exports) of Denmark in 2012 to that in 2013?
Provide a succinct answer. 0.97. What is the ratio of the Exports(as % of merchandise exports) in Namibia in 2012 to that in 2013?
Provide a succinct answer. 1.15. What is the difference between the highest and the second highest Exports(as % of merchandise exports) of Brunei Darussalam?
Your answer should be very brief. 0.07. What is the difference between the highest and the second highest Exports(as % of merchandise exports) in Bulgaria?
Your answer should be compact. 2.25. What is the difference between the highest and the second highest Exports(as % of merchandise exports) of Denmark?
Make the answer very short. 0.09. What is the difference between the highest and the second highest Exports(as % of merchandise exports) in Namibia?
Your answer should be very brief. 10.79. What is the difference between the highest and the lowest Exports(as % of merchandise exports) of Brunei Darussalam?
Offer a very short reply. 0.14. What is the difference between the highest and the lowest Exports(as % of merchandise exports) of Bulgaria?
Your answer should be compact. 9.03. What is the difference between the highest and the lowest Exports(as % of merchandise exports) of Denmark?
Provide a short and direct response. 1.86. What is the difference between the highest and the lowest Exports(as % of merchandise exports) of Namibia?
Provide a succinct answer. 24.14. 